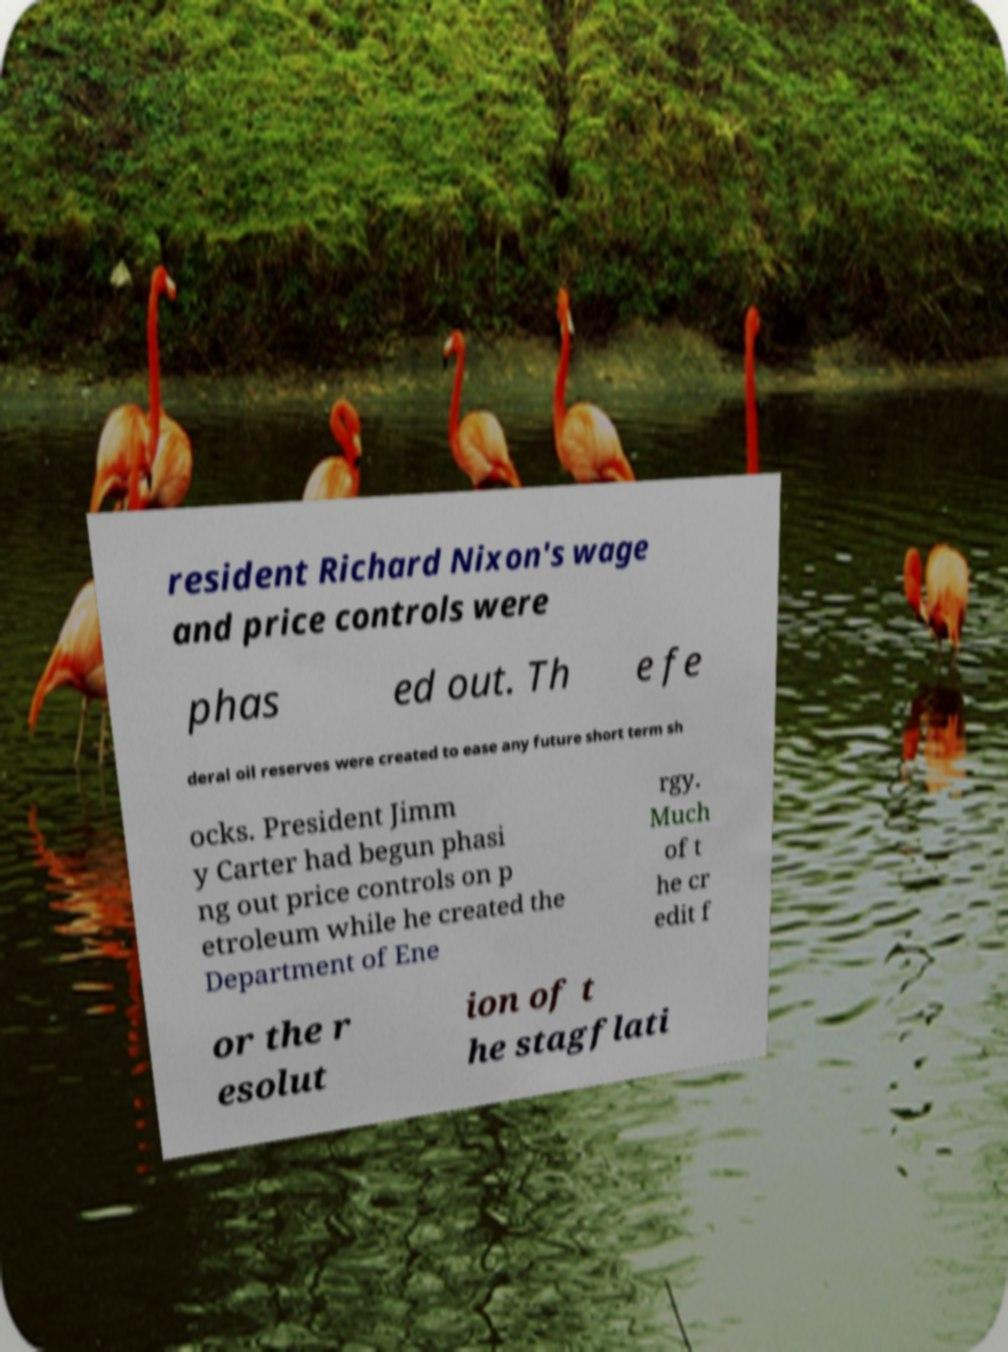Could you assist in decoding the text presented in this image and type it out clearly? resident Richard Nixon's wage and price controls were phas ed out. Th e fe deral oil reserves were created to ease any future short term sh ocks. President Jimm y Carter had begun phasi ng out price controls on p etroleum while he created the Department of Ene rgy. Much of t he cr edit f or the r esolut ion of t he stagflati 